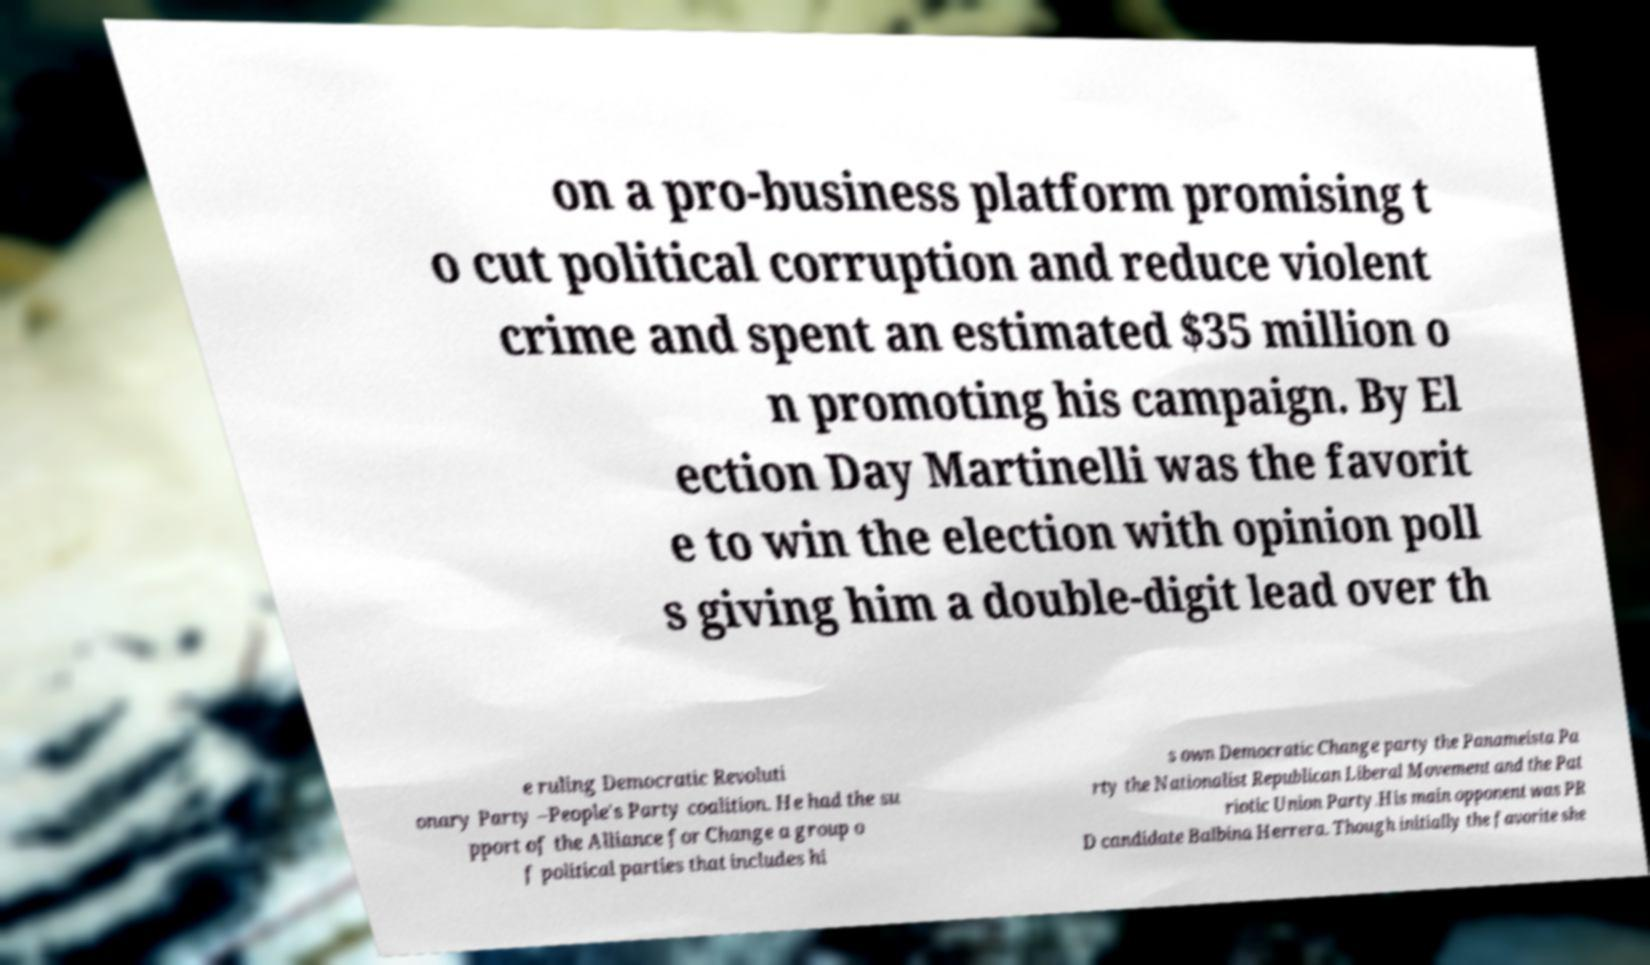Could you extract and type out the text from this image? on a pro-business platform promising t o cut political corruption and reduce violent crime and spent an estimated $35 million o n promoting his campaign. By El ection Day Martinelli was the favorit e to win the election with opinion poll s giving him a double-digit lead over th e ruling Democratic Revoluti onary Party –People's Party coalition. He had the su pport of the Alliance for Change a group o f political parties that includes hi s own Democratic Change party the Panameista Pa rty the Nationalist Republican Liberal Movement and the Pat riotic Union Party.His main opponent was PR D candidate Balbina Herrera. Though initially the favorite she 